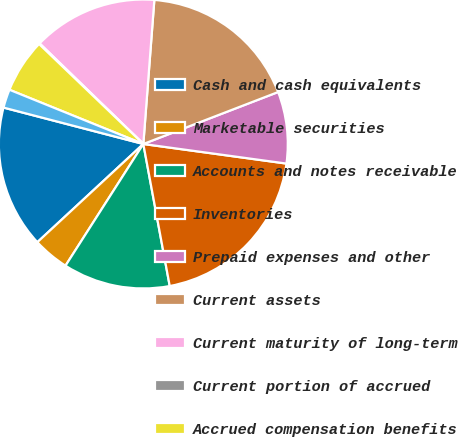Convert chart to OTSL. <chart><loc_0><loc_0><loc_500><loc_500><pie_chart><fcel>Cash and cash equivalents<fcel>Marketable securities<fcel>Accounts and notes receivable<fcel>Inventories<fcel>Prepaid expenses and other<fcel>Current assets<fcel>Current maturity of long-term<fcel>Current portion of accrued<fcel>Accrued compensation benefits<fcel>Taxes payable (including taxes<nl><fcel>15.95%<fcel>4.05%<fcel>11.98%<fcel>19.91%<fcel>8.02%<fcel>17.93%<fcel>13.96%<fcel>0.09%<fcel>6.04%<fcel>2.07%<nl></chart> 